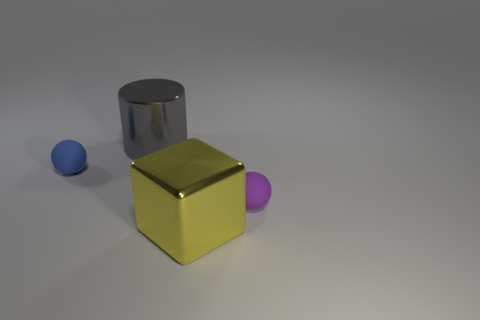Subtract all cylinders. How many objects are left? 3 Subtract all gray balls. Subtract all gray blocks. How many balls are left? 2 Subtract all red blocks. How many red spheres are left? 0 Subtract all gray metal objects. Subtract all big yellow metallic blocks. How many objects are left? 2 Add 2 large gray things. How many large gray things are left? 3 Add 3 metallic cylinders. How many metallic cylinders exist? 4 Add 2 large gray matte objects. How many objects exist? 6 Subtract 1 blue balls. How many objects are left? 3 